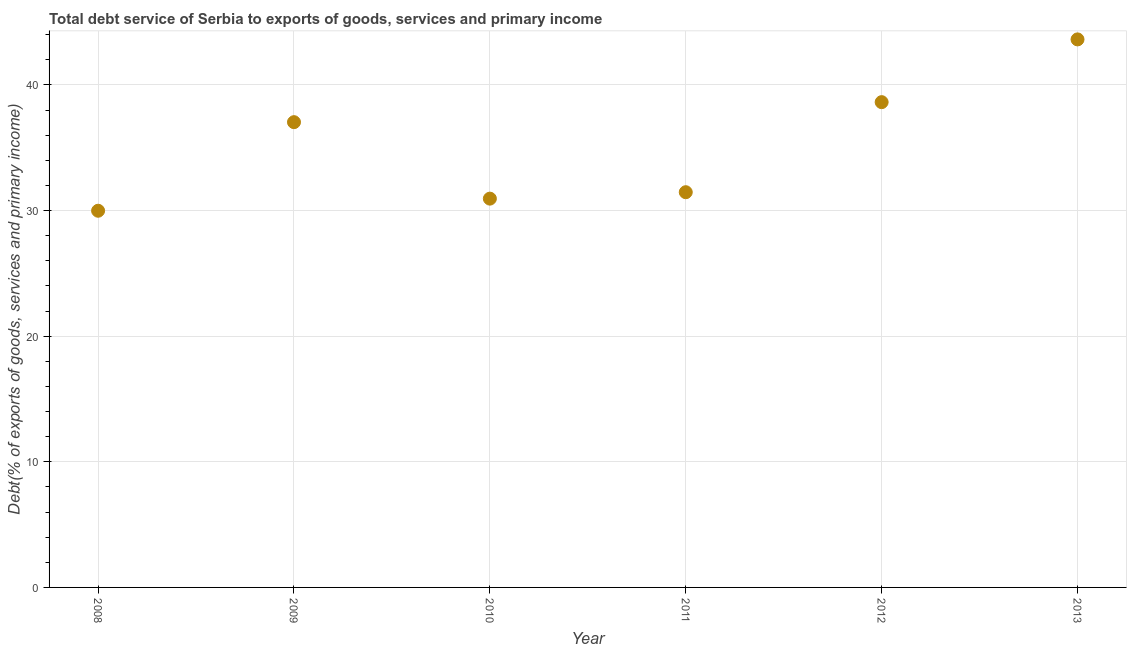What is the total debt service in 2009?
Offer a very short reply. 37.04. Across all years, what is the maximum total debt service?
Provide a short and direct response. 43.63. Across all years, what is the minimum total debt service?
Offer a very short reply. 29.99. What is the sum of the total debt service?
Offer a terse response. 211.69. What is the difference between the total debt service in 2010 and 2011?
Offer a very short reply. -0.51. What is the average total debt service per year?
Provide a short and direct response. 35.28. What is the median total debt service?
Offer a very short reply. 34.25. What is the ratio of the total debt service in 2008 to that in 2012?
Ensure brevity in your answer.  0.78. Is the total debt service in 2011 less than that in 2012?
Provide a short and direct response. Yes. Is the difference between the total debt service in 2009 and 2011 greater than the difference between any two years?
Offer a very short reply. No. What is the difference between the highest and the second highest total debt service?
Your answer should be compact. 5. Is the sum of the total debt service in 2010 and 2013 greater than the maximum total debt service across all years?
Provide a succinct answer. Yes. What is the difference between the highest and the lowest total debt service?
Your response must be concise. 13.64. Does the total debt service monotonically increase over the years?
Your answer should be very brief. No. How many dotlines are there?
Your answer should be very brief. 1. What is the difference between two consecutive major ticks on the Y-axis?
Your answer should be very brief. 10. Are the values on the major ticks of Y-axis written in scientific E-notation?
Give a very brief answer. No. What is the title of the graph?
Ensure brevity in your answer.  Total debt service of Serbia to exports of goods, services and primary income. What is the label or title of the X-axis?
Give a very brief answer. Year. What is the label or title of the Y-axis?
Give a very brief answer. Debt(% of exports of goods, services and primary income). What is the Debt(% of exports of goods, services and primary income) in 2008?
Your answer should be compact. 29.99. What is the Debt(% of exports of goods, services and primary income) in 2009?
Keep it short and to the point. 37.04. What is the Debt(% of exports of goods, services and primary income) in 2010?
Give a very brief answer. 30.95. What is the Debt(% of exports of goods, services and primary income) in 2011?
Offer a very short reply. 31.46. What is the Debt(% of exports of goods, services and primary income) in 2012?
Make the answer very short. 38.63. What is the Debt(% of exports of goods, services and primary income) in 2013?
Make the answer very short. 43.63. What is the difference between the Debt(% of exports of goods, services and primary income) in 2008 and 2009?
Offer a terse response. -7.05. What is the difference between the Debt(% of exports of goods, services and primary income) in 2008 and 2010?
Offer a terse response. -0.96. What is the difference between the Debt(% of exports of goods, services and primary income) in 2008 and 2011?
Offer a terse response. -1.48. What is the difference between the Debt(% of exports of goods, services and primary income) in 2008 and 2012?
Give a very brief answer. -8.64. What is the difference between the Debt(% of exports of goods, services and primary income) in 2008 and 2013?
Your response must be concise. -13.64. What is the difference between the Debt(% of exports of goods, services and primary income) in 2009 and 2010?
Your answer should be very brief. 6.09. What is the difference between the Debt(% of exports of goods, services and primary income) in 2009 and 2011?
Keep it short and to the point. 5.58. What is the difference between the Debt(% of exports of goods, services and primary income) in 2009 and 2012?
Give a very brief answer. -1.59. What is the difference between the Debt(% of exports of goods, services and primary income) in 2009 and 2013?
Your answer should be very brief. -6.59. What is the difference between the Debt(% of exports of goods, services and primary income) in 2010 and 2011?
Offer a very short reply. -0.51. What is the difference between the Debt(% of exports of goods, services and primary income) in 2010 and 2012?
Make the answer very short. -7.68. What is the difference between the Debt(% of exports of goods, services and primary income) in 2010 and 2013?
Make the answer very short. -12.68. What is the difference between the Debt(% of exports of goods, services and primary income) in 2011 and 2012?
Give a very brief answer. -7.17. What is the difference between the Debt(% of exports of goods, services and primary income) in 2011 and 2013?
Keep it short and to the point. -12.16. What is the difference between the Debt(% of exports of goods, services and primary income) in 2012 and 2013?
Offer a very short reply. -5. What is the ratio of the Debt(% of exports of goods, services and primary income) in 2008 to that in 2009?
Your response must be concise. 0.81. What is the ratio of the Debt(% of exports of goods, services and primary income) in 2008 to that in 2011?
Your response must be concise. 0.95. What is the ratio of the Debt(% of exports of goods, services and primary income) in 2008 to that in 2012?
Give a very brief answer. 0.78. What is the ratio of the Debt(% of exports of goods, services and primary income) in 2008 to that in 2013?
Give a very brief answer. 0.69. What is the ratio of the Debt(% of exports of goods, services and primary income) in 2009 to that in 2010?
Provide a short and direct response. 1.2. What is the ratio of the Debt(% of exports of goods, services and primary income) in 2009 to that in 2011?
Offer a very short reply. 1.18. What is the ratio of the Debt(% of exports of goods, services and primary income) in 2009 to that in 2012?
Your response must be concise. 0.96. What is the ratio of the Debt(% of exports of goods, services and primary income) in 2009 to that in 2013?
Provide a short and direct response. 0.85. What is the ratio of the Debt(% of exports of goods, services and primary income) in 2010 to that in 2011?
Keep it short and to the point. 0.98. What is the ratio of the Debt(% of exports of goods, services and primary income) in 2010 to that in 2012?
Your response must be concise. 0.8. What is the ratio of the Debt(% of exports of goods, services and primary income) in 2010 to that in 2013?
Give a very brief answer. 0.71. What is the ratio of the Debt(% of exports of goods, services and primary income) in 2011 to that in 2012?
Make the answer very short. 0.81. What is the ratio of the Debt(% of exports of goods, services and primary income) in 2011 to that in 2013?
Keep it short and to the point. 0.72. What is the ratio of the Debt(% of exports of goods, services and primary income) in 2012 to that in 2013?
Provide a short and direct response. 0.89. 